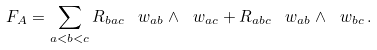Convert formula to latex. <formula><loc_0><loc_0><loc_500><loc_500>\ F _ { A } = \sum _ { a < b < c } R _ { b a c } \, \ w _ { a b } \wedge \ w _ { a c } + R _ { a b c } \, \ w _ { a b } \wedge \ w _ { b c } \, .</formula> 